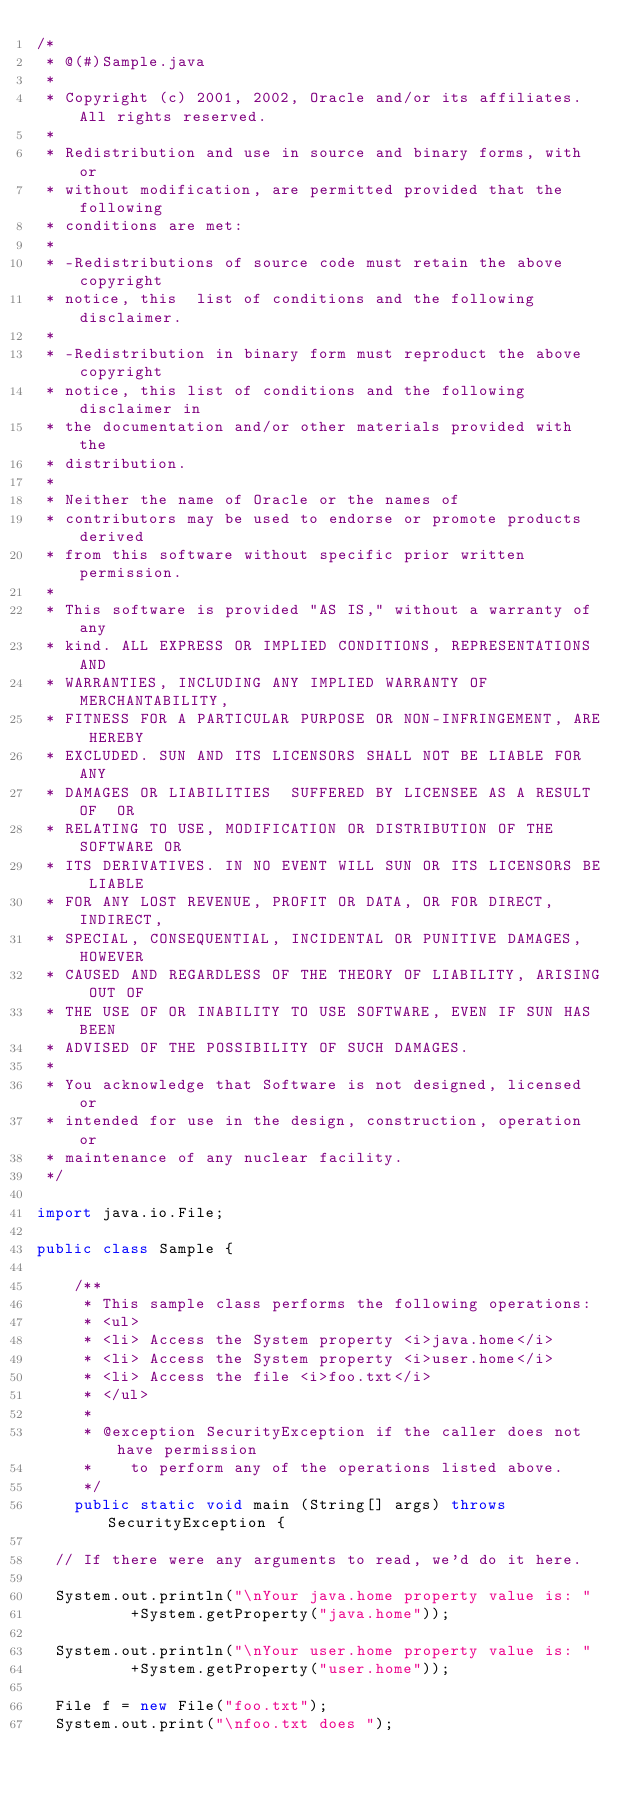Convert code to text. <code><loc_0><loc_0><loc_500><loc_500><_Java_>/*
 * @(#)Sample.java
 *
 * Copyright (c) 2001, 2002, Oracle and/or its affiliates. All rights reserved.
 *
 * Redistribution and use in source and binary forms, with or 
 * without modification, are permitted provided that the following 
 * conditions are met:
 * 
 * -Redistributions of source code must retain the above copyright  
 * notice, this  list of conditions and the following disclaimer.
 * 
 * -Redistribution in binary form must reproduct the above copyright 
 * notice, this list of conditions and the following disclaimer in 
 * the documentation and/or other materials provided with the 
 * distribution.
 * 
 * Neither the name of Oracle or the names of 
 * contributors may be used to endorse or promote products derived 
 * from this software without specific prior written permission.
 * 
 * This software is provided "AS IS," without a warranty of any 
 * kind. ALL EXPRESS OR IMPLIED CONDITIONS, REPRESENTATIONS AND 
 * WARRANTIES, INCLUDING ANY IMPLIED WARRANTY OF MERCHANTABILITY, 
 * FITNESS FOR A PARTICULAR PURPOSE OR NON-INFRINGEMENT, ARE HEREBY 
 * EXCLUDED. SUN AND ITS LICENSORS SHALL NOT BE LIABLE FOR ANY 
 * DAMAGES OR LIABILITIES  SUFFERED BY LICENSEE AS A RESULT OF  OR 
 * RELATING TO USE, MODIFICATION OR DISTRIBUTION OF THE SOFTWARE OR 
 * ITS DERIVATIVES. IN NO EVENT WILL SUN OR ITS LICENSORS BE LIABLE 
 * FOR ANY LOST REVENUE, PROFIT OR DATA, OR FOR DIRECT, INDIRECT, 
 * SPECIAL, CONSEQUENTIAL, INCIDENTAL OR PUNITIVE DAMAGES, HOWEVER 
 * CAUSED AND REGARDLESS OF THE THEORY OF LIABILITY, ARISING OUT OF 
 * THE USE OF OR INABILITY TO USE SOFTWARE, EVEN IF SUN HAS BEEN 
 * ADVISED OF THE POSSIBILITY OF SUCH DAMAGES.
 * 
 * You acknowledge that Software is not designed, licensed or 
 * intended for use in the design, construction, operation or 
 * maintenance of any nuclear facility. 
 */

import java.io.File;

public class Sample {

    /**
     * This sample class performs the following operations:
     * <ul>
     * <li> Access the System property <i>java.home</i>
     * <li> Access the System property <i>user.home</i>
     * <li> Access the file <i>foo.txt</i>
     * </ul>
     *
     * @exception SecurityException if the caller does not have permission
     *		to perform any of the operations listed above.
     */
    public static void main (String[] args) throws SecurityException {

	// If there were any arguments to read, we'd do it here.

	System.out.println("\nYour java.home property value is: "
			    +System.getProperty("java.home"));

	System.out.println("\nYour user.home property value is: "
			    +System.getProperty("user.home"));

	File f = new File("foo.txt");
	System.out.print("\nfoo.txt does ");</code> 